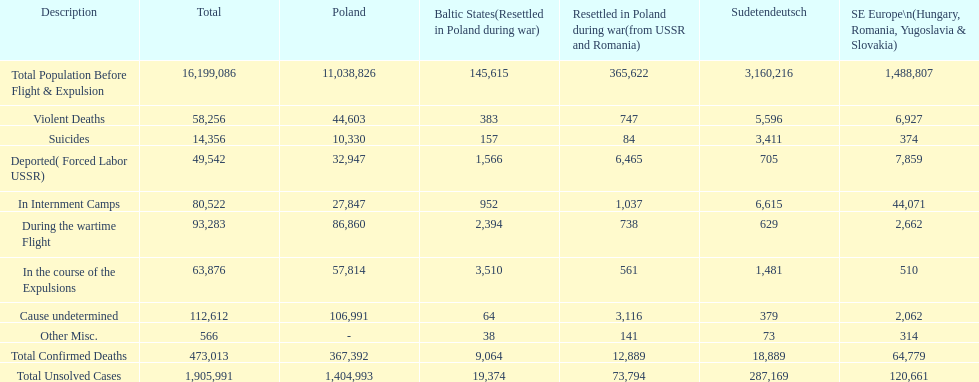Which had a greater total population before expulsion: poland or sudetendeutsch? Poland. 